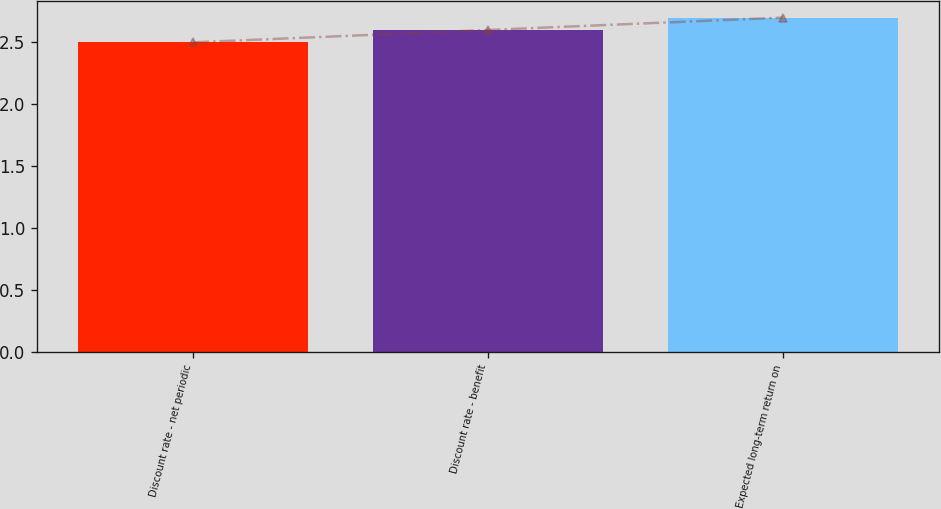Convert chart to OTSL. <chart><loc_0><loc_0><loc_500><loc_500><bar_chart><fcel>Discount rate - net periodic<fcel>Discount rate - benefit<fcel>Expected long-term return on<nl><fcel>2.5<fcel>2.6<fcel>2.7<nl></chart> 